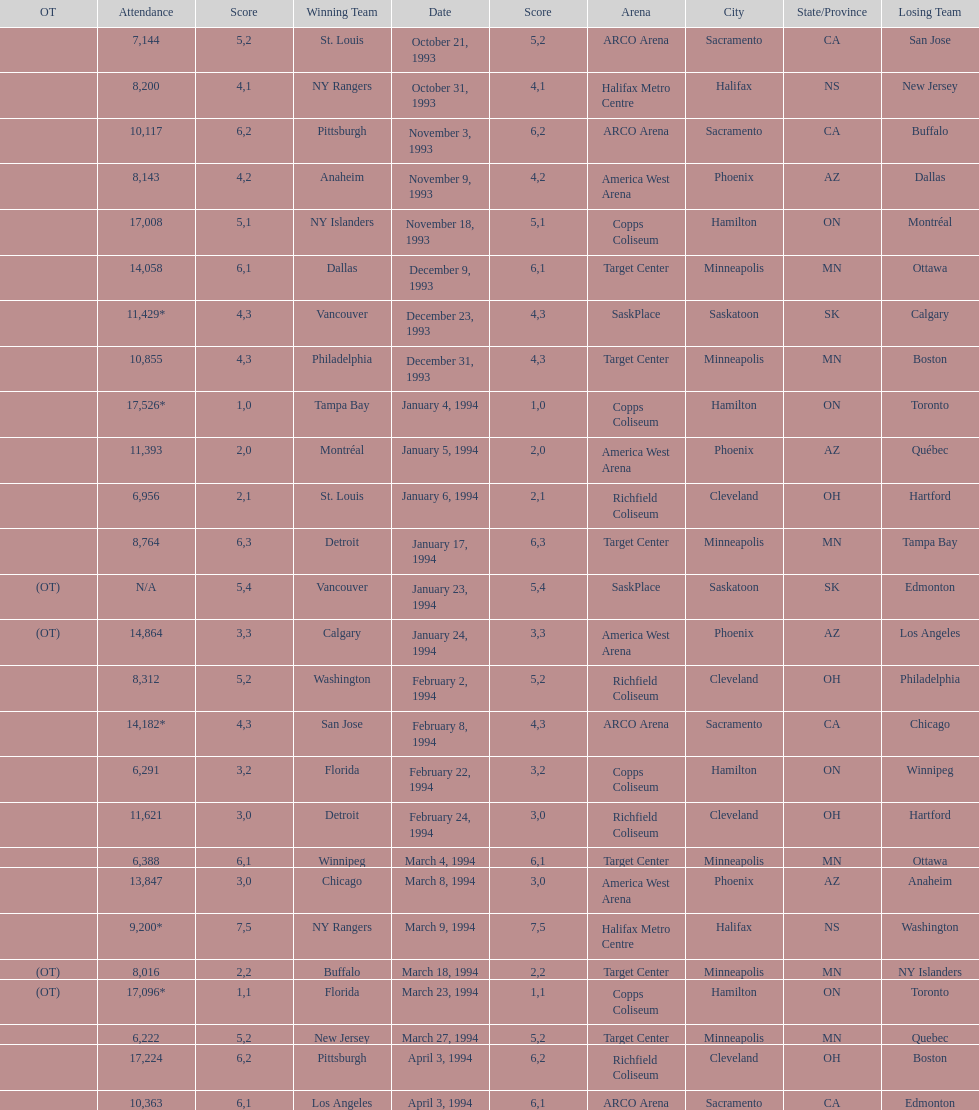When was the first neutral site game to be won by tampa bay? January 4, 1994. 